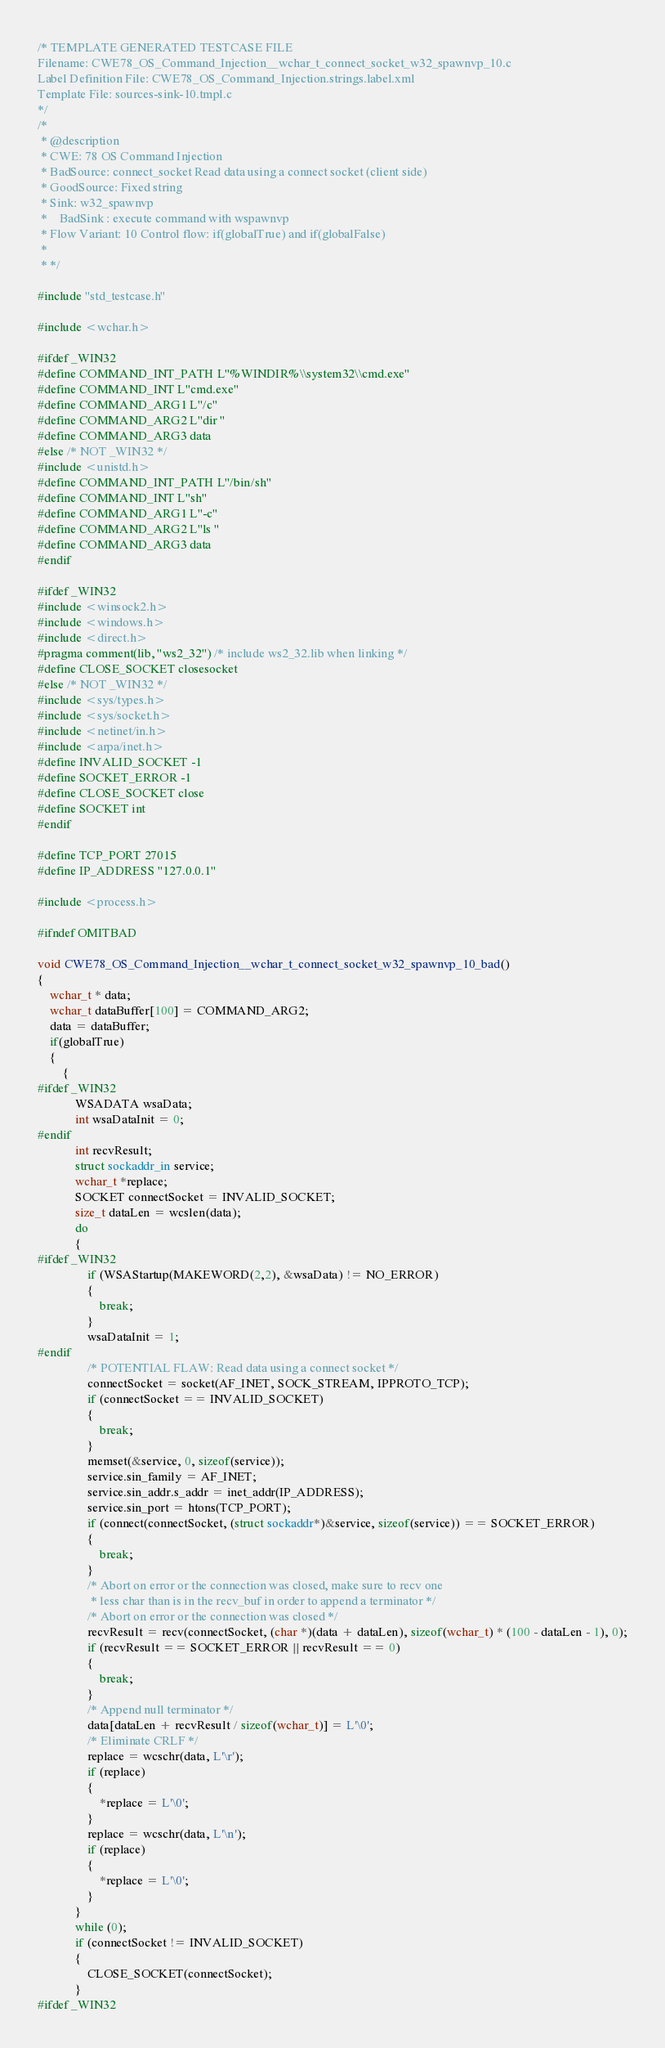<code> <loc_0><loc_0><loc_500><loc_500><_C_>/* TEMPLATE GENERATED TESTCASE FILE
Filename: CWE78_OS_Command_Injection__wchar_t_connect_socket_w32_spawnvp_10.c
Label Definition File: CWE78_OS_Command_Injection.strings.label.xml
Template File: sources-sink-10.tmpl.c
*/
/*
 * @description
 * CWE: 78 OS Command Injection
 * BadSource: connect_socket Read data using a connect socket (client side)
 * GoodSource: Fixed string
 * Sink: w32_spawnvp
 *    BadSink : execute command with wspawnvp
 * Flow Variant: 10 Control flow: if(globalTrue) and if(globalFalse)
 *
 * */

#include "std_testcase.h"

#include <wchar.h>

#ifdef _WIN32
#define COMMAND_INT_PATH L"%WINDIR%\\system32\\cmd.exe"
#define COMMAND_INT L"cmd.exe"
#define COMMAND_ARG1 L"/c"
#define COMMAND_ARG2 L"dir "
#define COMMAND_ARG3 data
#else /* NOT _WIN32 */
#include <unistd.h>
#define COMMAND_INT_PATH L"/bin/sh"
#define COMMAND_INT L"sh"
#define COMMAND_ARG1 L"-c"
#define COMMAND_ARG2 L"ls "
#define COMMAND_ARG3 data
#endif

#ifdef _WIN32
#include <winsock2.h>
#include <windows.h>
#include <direct.h>
#pragma comment(lib, "ws2_32") /* include ws2_32.lib when linking */
#define CLOSE_SOCKET closesocket
#else /* NOT _WIN32 */
#include <sys/types.h>
#include <sys/socket.h>
#include <netinet/in.h>
#include <arpa/inet.h>
#define INVALID_SOCKET -1
#define SOCKET_ERROR -1
#define CLOSE_SOCKET close
#define SOCKET int
#endif

#define TCP_PORT 27015
#define IP_ADDRESS "127.0.0.1"

#include <process.h>

#ifndef OMITBAD

void CWE78_OS_Command_Injection__wchar_t_connect_socket_w32_spawnvp_10_bad()
{
    wchar_t * data;
    wchar_t dataBuffer[100] = COMMAND_ARG2;
    data = dataBuffer;
    if(globalTrue)
    {
        {
#ifdef _WIN32
            WSADATA wsaData;
            int wsaDataInit = 0;
#endif
            int recvResult;
            struct sockaddr_in service;
            wchar_t *replace;
            SOCKET connectSocket = INVALID_SOCKET;
            size_t dataLen = wcslen(data);
            do
            {
#ifdef _WIN32
                if (WSAStartup(MAKEWORD(2,2), &wsaData) != NO_ERROR)
                {
                    break;
                }
                wsaDataInit = 1;
#endif
                /* POTENTIAL FLAW: Read data using a connect socket */
                connectSocket = socket(AF_INET, SOCK_STREAM, IPPROTO_TCP);
                if (connectSocket == INVALID_SOCKET)
                {
                    break;
                }
                memset(&service, 0, sizeof(service));
                service.sin_family = AF_INET;
                service.sin_addr.s_addr = inet_addr(IP_ADDRESS);
                service.sin_port = htons(TCP_PORT);
                if (connect(connectSocket, (struct sockaddr*)&service, sizeof(service)) == SOCKET_ERROR)
                {
                    break;
                }
                /* Abort on error or the connection was closed, make sure to recv one
                 * less char than is in the recv_buf in order to append a terminator */
                /* Abort on error or the connection was closed */
                recvResult = recv(connectSocket, (char *)(data + dataLen), sizeof(wchar_t) * (100 - dataLen - 1), 0);
                if (recvResult == SOCKET_ERROR || recvResult == 0)
                {
                    break;
                }
                /* Append null terminator */
                data[dataLen + recvResult / sizeof(wchar_t)] = L'\0';
                /* Eliminate CRLF */
                replace = wcschr(data, L'\r');
                if (replace)
                {
                    *replace = L'\0';
                }
                replace = wcschr(data, L'\n');
                if (replace)
                {
                    *replace = L'\0';
                }
            }
            while (0);
            if (connectSocket != INVALID_SOCKET)
            {
                CLOSE_SOCKET(connectSocket);
            }
#ifdef _WIN32</code> 